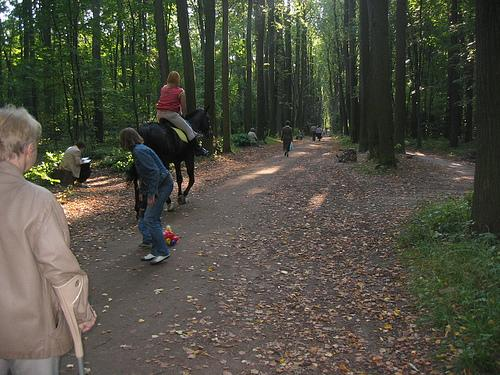What is helping someone walk?

Choices:
A) crutches
B) branch
C) walker
D) cane crutches 